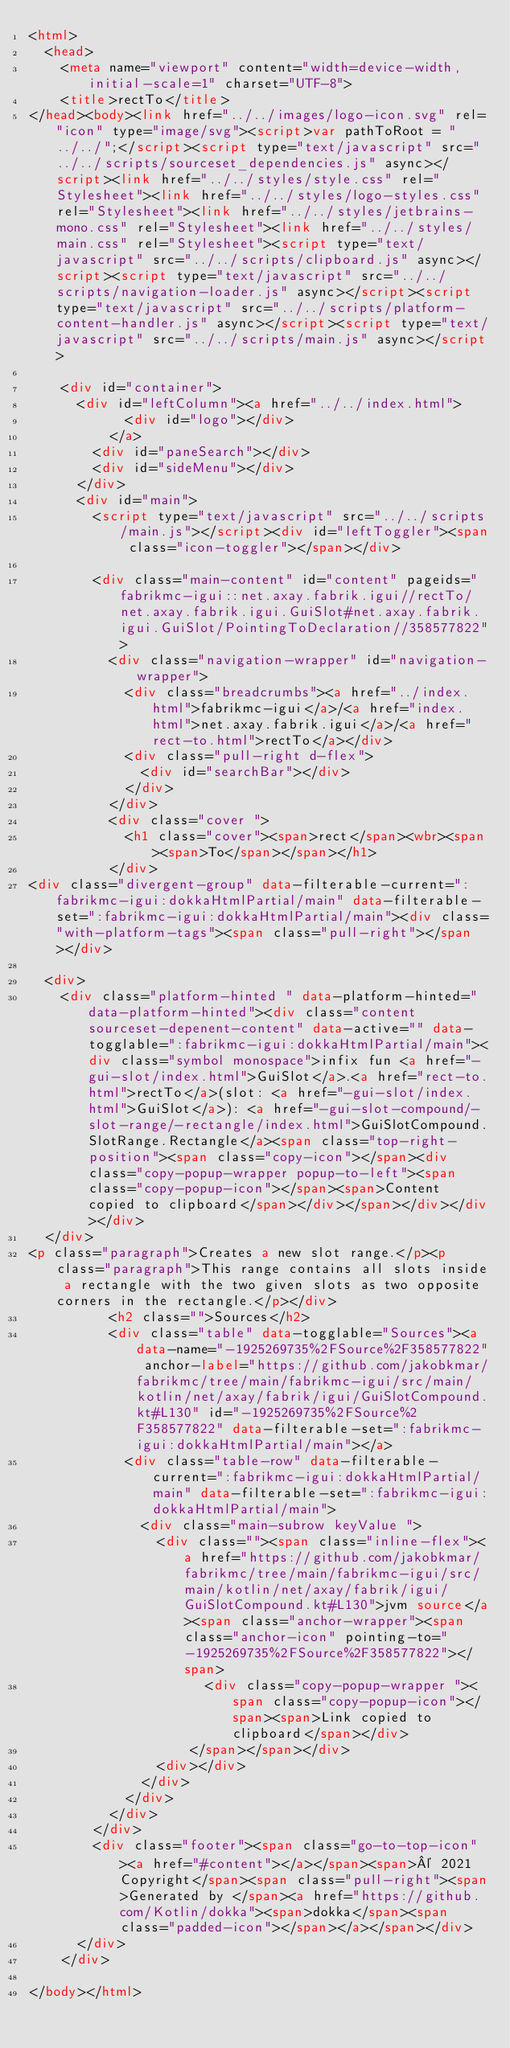<code> <loc_0><loc_0><loc_500><loc_500><_HTML_><html>
  <head>
    <meta name="viewport" content="width=device-width, initial-scale=1" charset="UTF-8">
    <title>rectTo</title>
</head><body><link href="../../images/logo-icon.svg" rel="icon" type="image/svg"><script>var pathToRoot = "../../";</script><script type="text/javascript" src="../../scripts/sourceset_dependencies.js" async></script><link href="../../styles/style.css" rel="Stylesheet"><link href="../../styles/logo-styles.css" rel="Stylesheet"><link href="../../styles/jetbrains-mono.css" rel="Stylesheet"><link href="../../styles/main.css" rel="Stylesheet"><script type="text/javascript" src="../../scripts/clipboard.js" async></script><script type="text/javascript" src="../../scripts/navigation-loader.js" async></script><script type="text/javascript" src="../../scripts/platform-content-handler.js" async></script><script type="text/javascript" src="../../scripts/main.js" async></script>
  
    <div id="container">
      <div id="leftColumn"><a href="../../index.html">
            <div id="logo"></div>
          </a>
        <div id="paneSearch"></div>
        <div id="sideMenu"></div>
      </div>
      <div id="main">
        <script type="text/javascript" src="../../scripts/main.js"></script><div id="leftToggler"><span class="icon-toggler"></span></div>

        <div class="main-content" id="content" pageids="fabrikmc-igui::net.axay.fabrik.igui//rectTo/net.axay.fabrik.igui.GuiSlot#net.axay.fabrik.igui.GuiSlot/PointingToDeclaration//358577822">
          <div class="navigation-wrapper" id="navigation-wrapper">
            <div class="breadcrumbs"><a href="../index.html">fabrikmc-igui</a>/<a href="index.html">net.axay.fabrik.igui</a>/<a href="rect-to.html">rectTo</a></div>
            <div class="pull-right d-flex">
              <div id="searchBar"></div>
            </div>
          </div>
          <div class="cover ">
            <h1 class="cover"><span>rect</span><wbr><span><span>To</span></span></h1>
          </div>
<div class="divergent-group" data-filterable-current=":fabrikmc-igui:dokkaHtmlPartial/main" data-filterable-set=":fabrikmc-igui:dokkaHtmlPartial/main"><div class="with-platform-tags"><span class="pull-right"></span></div>

  <div>
    <div class="platform-hinted " data-platform-hinted="data-platform-hinted"><div class="content sourceset-depenent-content" data-active="" data-togglable=":fabrikmc-igui:dokkaHtmlPartial/main"><div class="symbol monospace">infix fun <a href="-gui-slot/index.html">GuiSlot</a>.<a href="rect-to.html">rectTo</a>(slot: <a href="-gui-slot/index.html">GuiSlot</a>): <a href="-gui-slot-compound/-slot-range/-rectangle/index.html">GuiSlotCompound.SlotRange.Rectangle</a><span class="top-right-position"><span class="copy-icon"></span><div class="copy-popup-wrapper popup-to-left"><span class="copy-popup-icon"></span><span>Content copied to clipboard</span></div></span></div></div></div>
  </div>
<p class="paragraph">Creates a new slot range.</p><p class="paragraph">This range contains all slots inside a rectangle with the two given slots as two opposite corners in the rectangle.</p></div>
          <h2 class="">Sources</h2>
          <div class="table" data-togglable="Sources"><a data-name="-1925269735%2FSource%2F358577822" anchor-label="https://github.com/jakobkmar/fabrikmc/tree/main/fabrikmc-igui/src/main/kotlin/net/axay/fabrik/igui/GuiSlotCompound.kt#L130" id="-1925269735%2FSource%2F358577822" data-filterable-set=":fabrikmc-igui:dokkaHtmlPartial/main"></a>
            <div class="table-row" data-filterable-current=":fabrikmc-igui:dokkaHtmlPartial/main" data-filterable-set=":fabrikmc-igui:dokkaHtmlPartial/main">
              <div class="main-subrow keyValue ">
                <div class=""><span class="inline-flex"><a href="https://github.com/jakobkmar/fabrikmc/tree/main/fabrikmc-igui/src/main/kotlin/net/axay/fabrik/igui/GuiSlotCompound.kt#L130">jvm source</a><span class="anchor-wrapper"><span class="anchor-icon" pointing-to="-1925269735%2FSource%2F358577822"></span>
                      <div class="copy-popup-wrapper "><span class="copy-popup-icon"></span><span>Link copied to clipboard</span></div>
                    </span></span></div>
                <div></div>
              </div>
            </div>
          </div>
        </div>
        <div class="footer"><span class="go-to-top-icon"><a href="#content"></a></span><span>© 2021 Copyright</span><span class="pull-right"><span>Generated by </span><a href="https://github.com/Kotlin/dokka"><span>dokka</span><span class="padded-icon"></span></a></span></div>
      </div>
    </div>
  
</body></html>


</code> 